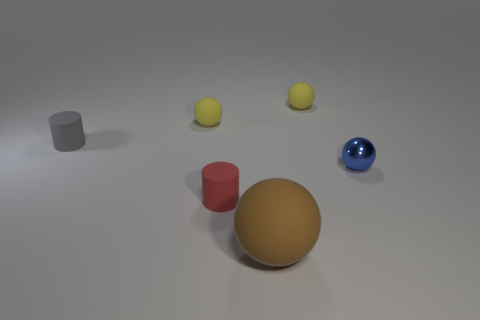Add 2 brown objects. How many objects exist? 8 Subtract all cylinders. How many objects are left? 4 Subtract all blue things. Subtract all red matte cylinders. How many objects are left? 4 Add 6 spheres. How many spheres are left? 10 Add 3 brown cylinders. How many brown cylinders exist? 3 Subtract 0 purple cylinders. How many objects are left? 6 